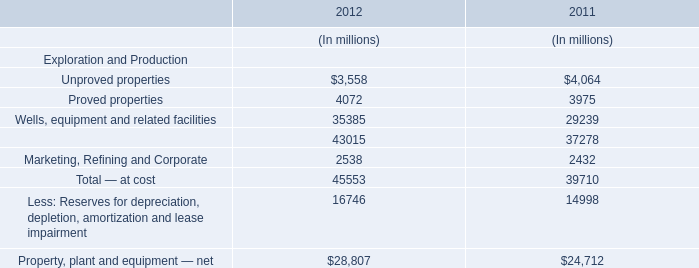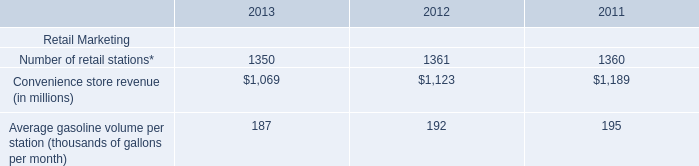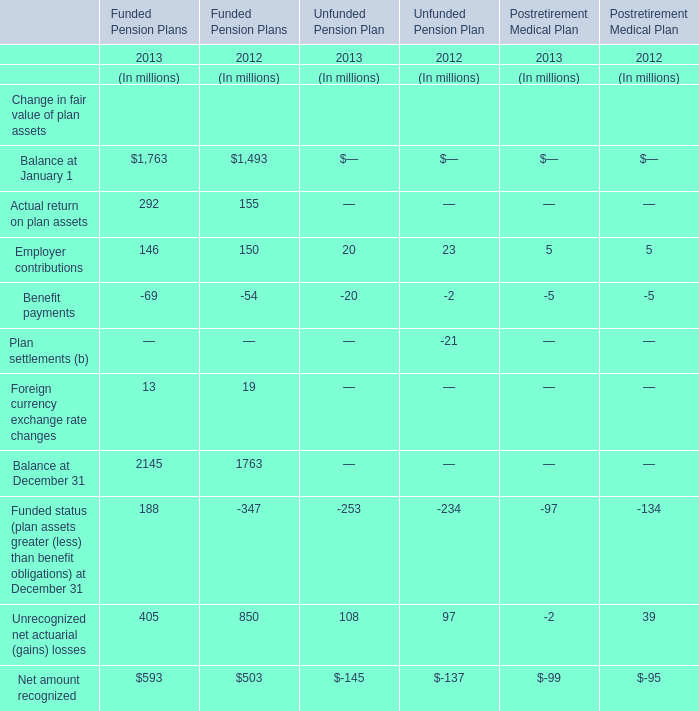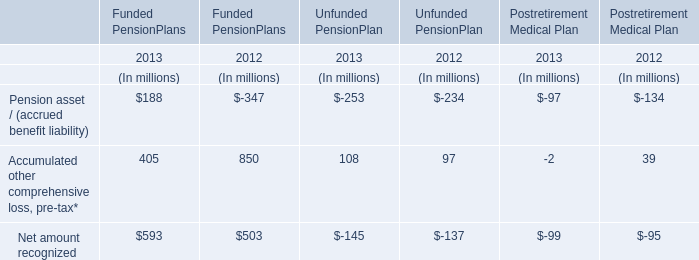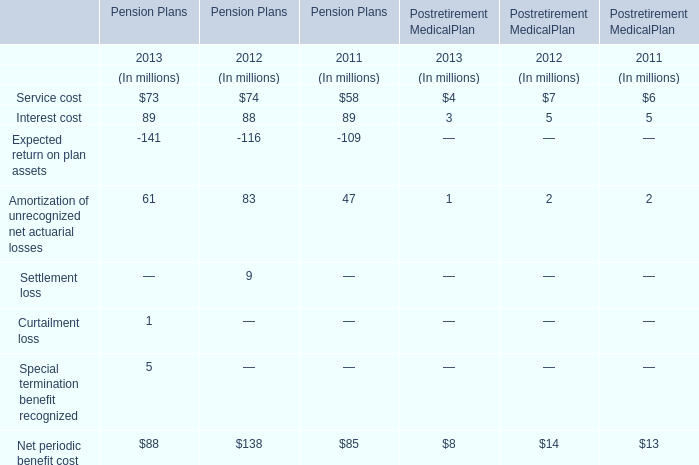What was the total amount of element greater than 100 in 2013 for Funded PensionPlans ? (in million) 
Computations: ((188 + 405) + 593)
Answer: 1186.0. 